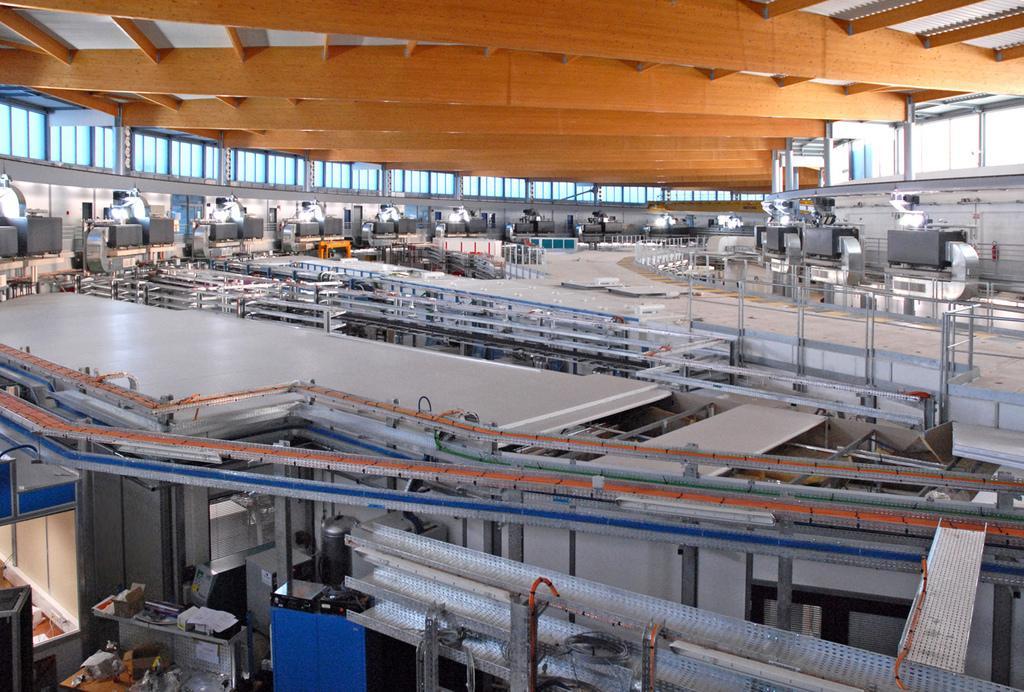How would you summarize this image in a sentence or two? This image looks like a factory with machines in the foreground. There is roof at the top. And there are windows on the left and right corner. 